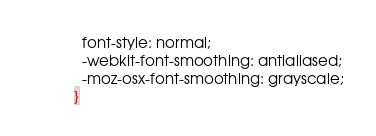Convert code to text. <code><loc_0><loc_0><loc_500><loc_500><_CSS_>  font-style: normal;
  -webkit-font-smoothing: antialiased;
  -moz-osx-font-smoothing: grayscale;
}

</code> 